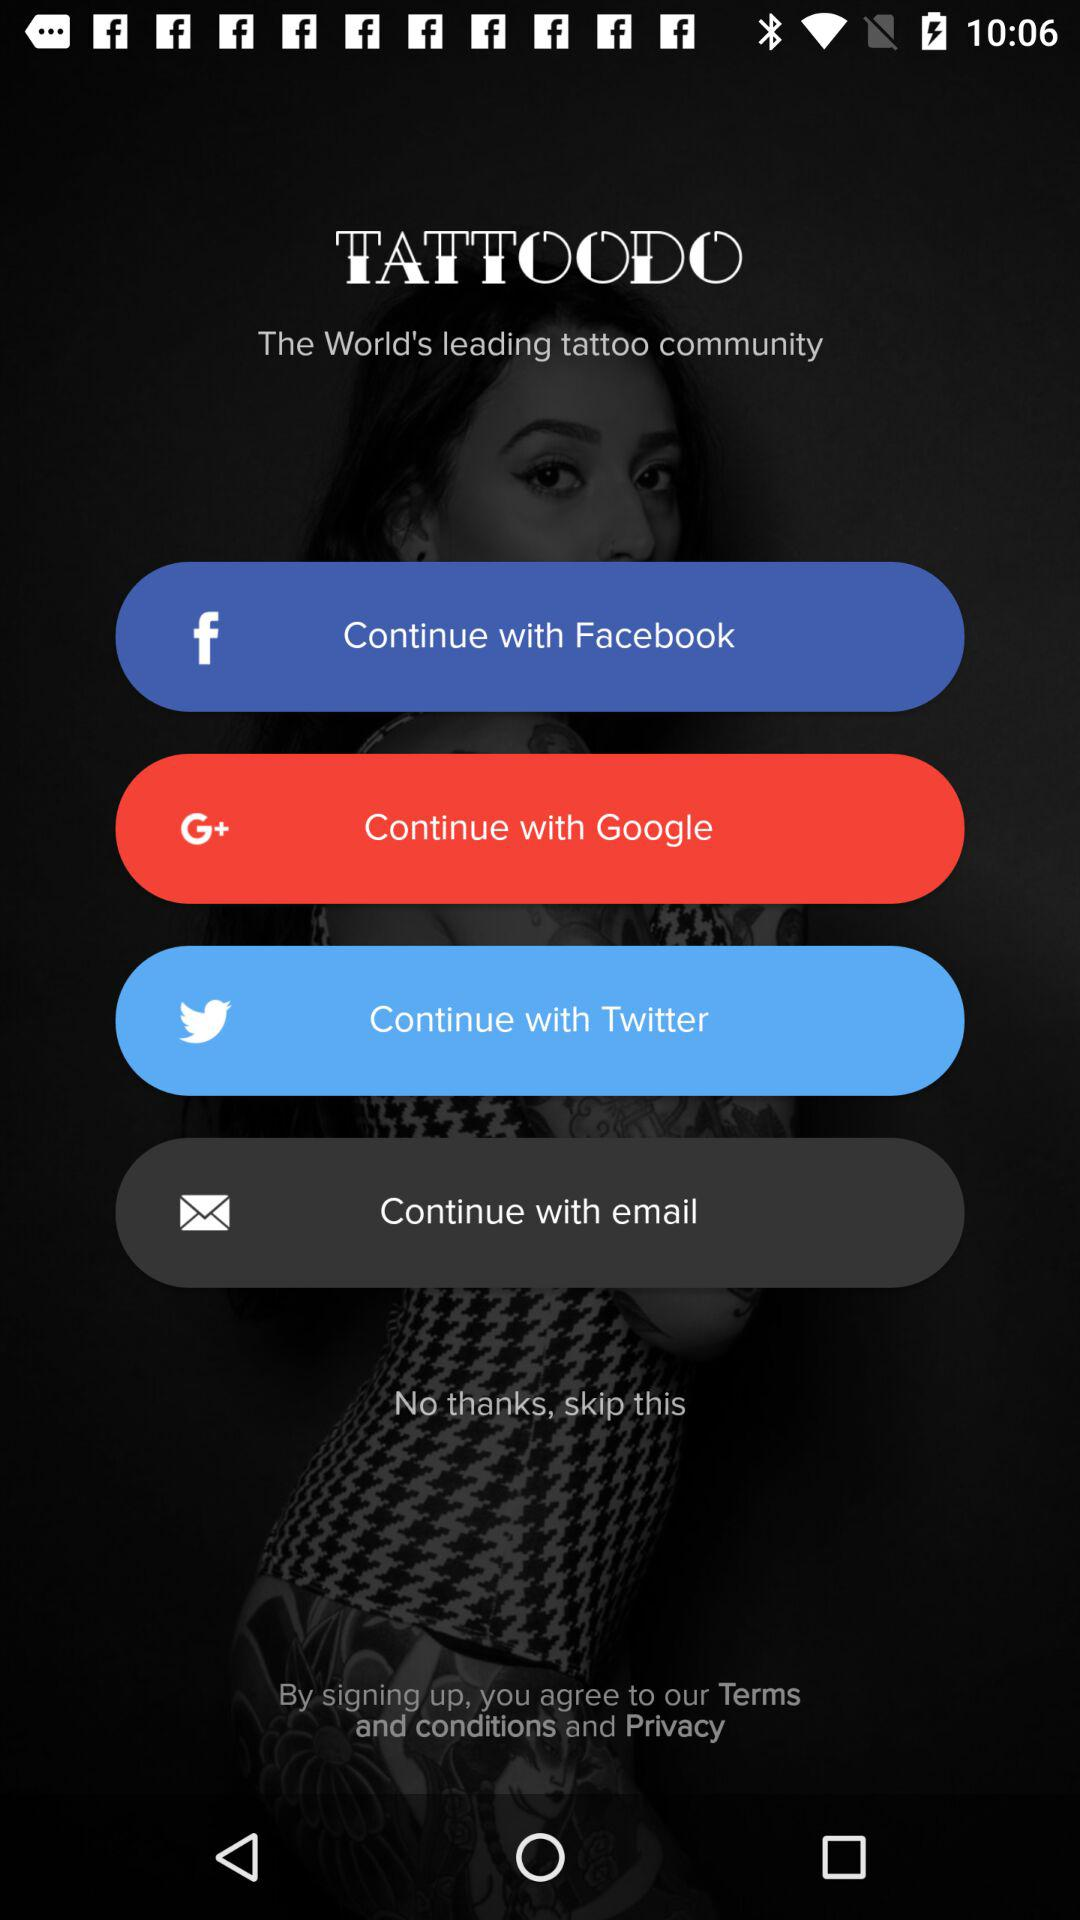What is the name of the application? The name of the application is "TATTOODO". 